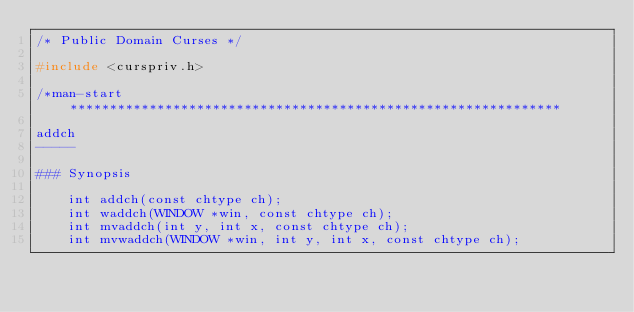<code> <loc_0><loc_0><loc_500><loc_500><_C_>/* Public Domain Curses */

#include <curspriv.h>

/*man-start**************************************************************

addch
-----

### Synopsis

    int addch(const chtype ch);
    int waddch(WINDOW *win, const chtype ch);
    int mvaddch(int y, int x, const chtype ch);
    int mvwaddch(WINDOW *win, int y, int x, const chtype ch);</code> 